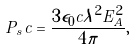Convert formula to latex. <formula><loc_0><loc_0><loc_500><loc_500>P _ { s } c = \frac { 3 \epsilon _ { 0 } c \lambda ^ { 2 } E _ { A } ^ { 2 } } { 4 \pi } ,</formula> 